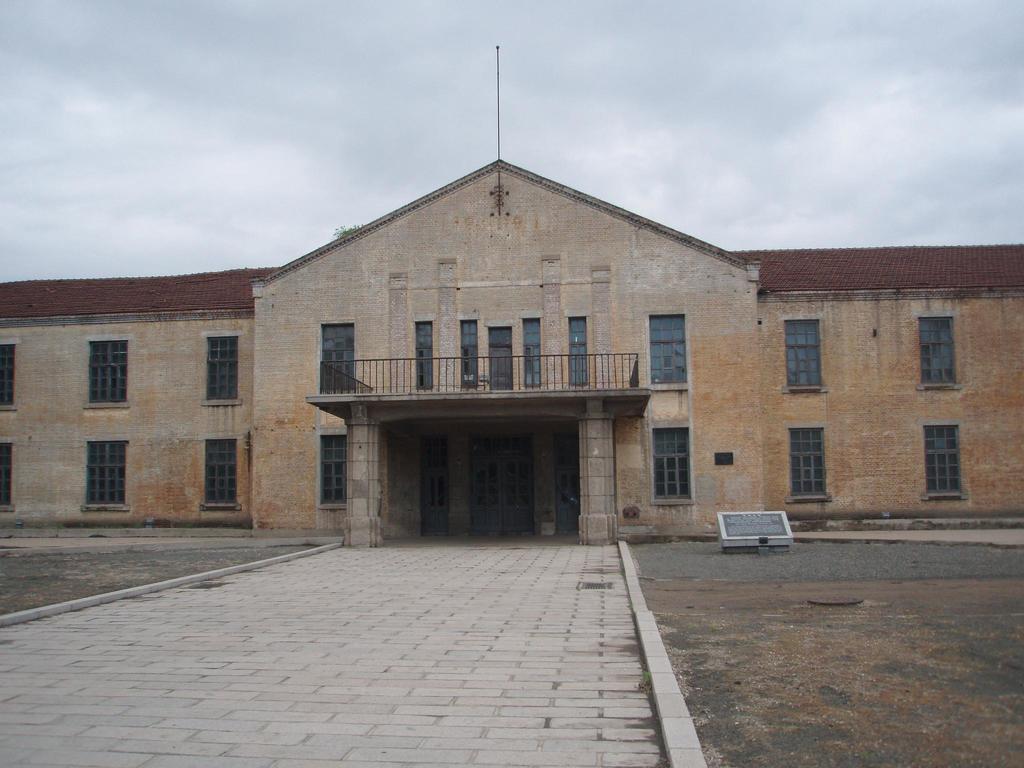Please provide a concise description of this image. In this image I can see a path, a building, number of windows, clouds and the sky. 